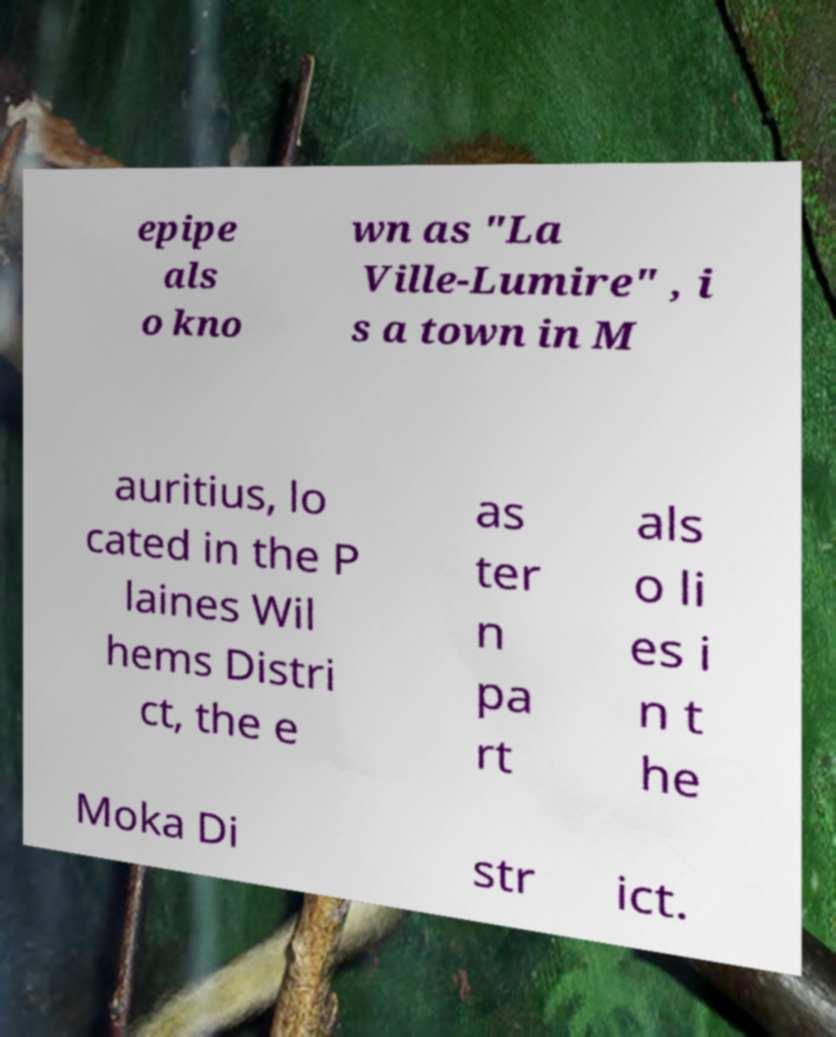I need the written content from this picture converted into text. Can you do that? epipe als o kno wn as "La Ville-Lumire" , i s a town in M auritius, lo cated in the P laines Wil hems Distri ct, the e as ter n pa rt als o li es i n t he Moka Di str ict. 